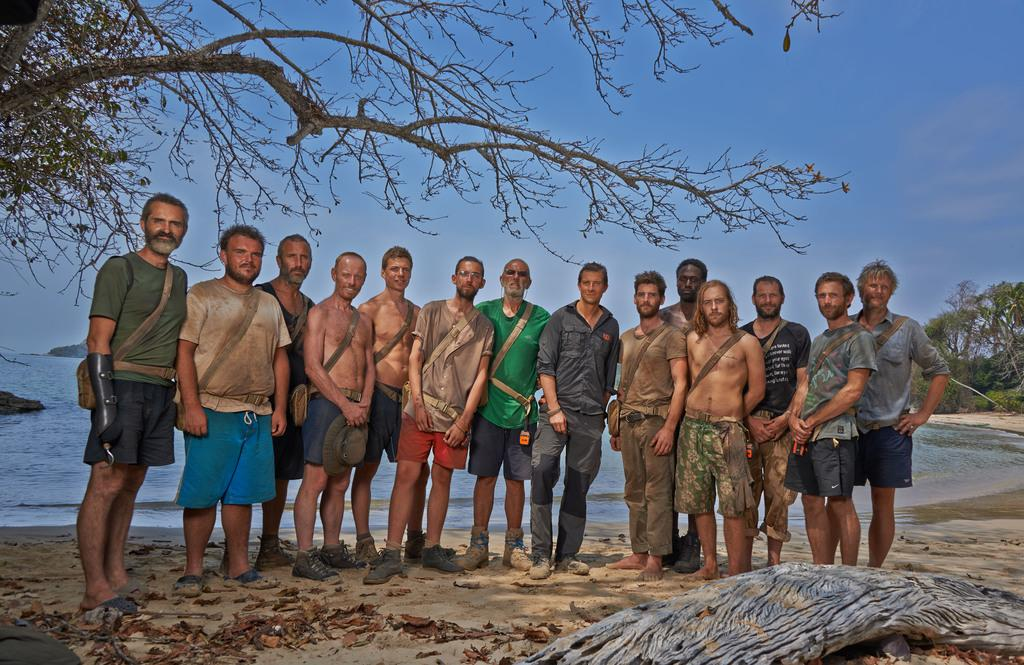How many people are in the image? There is a group of people in the image, but the exact number is not specified. Where are the people standing in the image? The people are standing on a path in the image. What can be seen in the background of the image? Trees, water, and the sky are visible in the background of the image. What type of bottle is being kicked around by the people in the image? There is no bottle present in the image, nor is there any indication of the people kicking anything. 